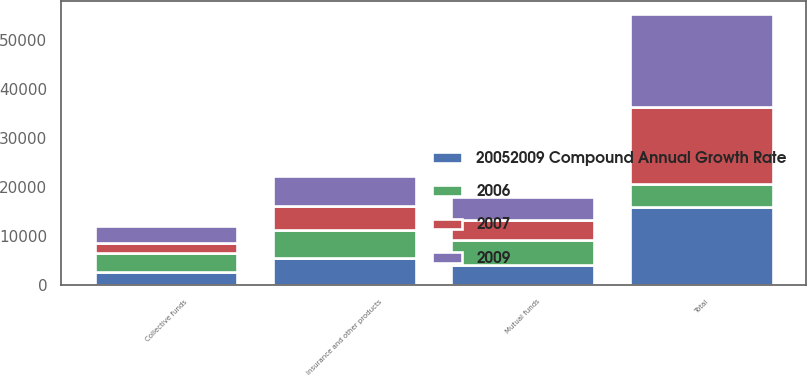Convert chart. <chart><loc_0><loc_0><loc_500><loc_500><stacked_bar_chart><ecel><fcel>Mutual funds<fcel>Collective funds<fcel>Insurance and other products<fcel>Total<nl><fcel>2009<fcel>4734<fcel>3580<fcel>6086<fcel>18795<nl><fcel>20052009 Compound Annual Growth Rate<fcel>4093<fcel>2679<fcel>5514<fcel>15907<nl><fcel>2006<fcel>5200<fcel>3968<fcel>5799<fcel>4780<nl><fcel>2007<fcel>4007<fcel>1947<fcel>4780<fcel>15648<nl></chart> 